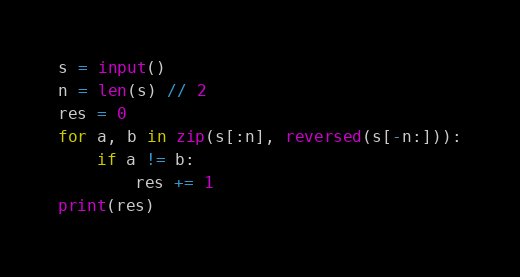Convert code to text. <code><loc_0><loc_0><loc_500><loc_500><_Python_>s = input()
n = len(s) // 2
res = 0
for a, b in zip(s[:n], reversed(s[-n:])):
    if a != b:
        res += 1
print(res)
</code> 